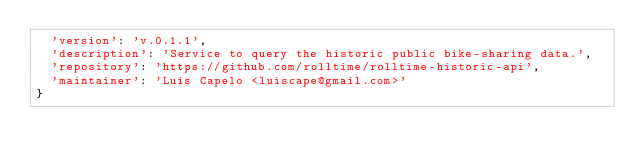Convert code to text. <code><loc_0><loc_0><loc_500><loc_500><_JavaScript_>  'version': 'v.0.1.1',
  'description': 'Service to query the historic public bike-sharing data.',
  'repository': 'https://github.com/rolltime/rolltime-historic-api',
  'maintainer': 'Luis Capelo <luiscape@gmail.com>'
}
</code> 